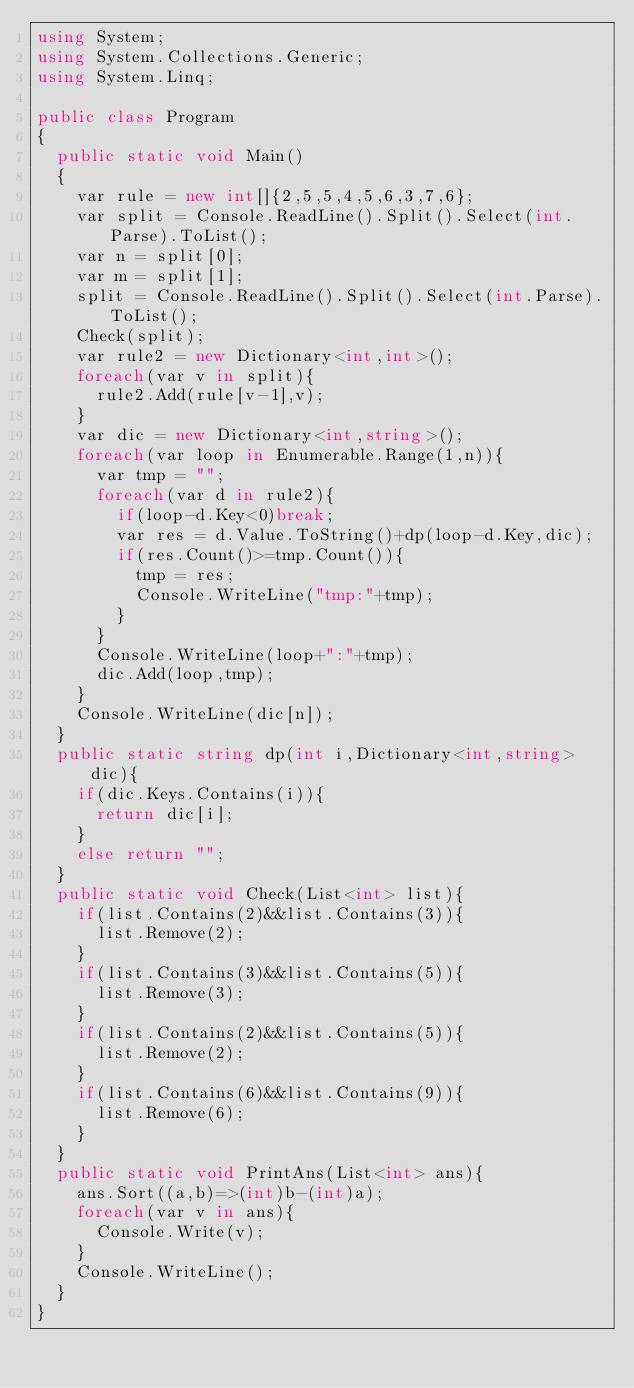<code> <loc_0><loc_0><loc_500><loc_500><_C#_>using System;
using System.Collections.Generic;
using System.Linq;
 
public class Program
{
	public static void Main()
	{
		var rule = new int[]{2,5,5,4,5,6,3,7,6};
		var split = Console.ReadLine().Split().Select(int.Parse).ToList();
		var n = split[0];
		var m = split[1];
		split = Console.ReadLine().Split().Select(int.Parse).ToList();
		Check(split);
		var rule2 = new Dictionary<int,int>();
		foreach(var v in split){
			rule2.Add(rule[v-1],v);
		}
		var dic = new Dictionary<int,string>();
		foreach(var loop in Enumerable.Range(1,n)){
			var tmp = "";
			foreach(var d in rule2){
				if(loop-d.Key<0)break;
				var res = d.Value.ToString()+dp(loop-d.Key,dic);
				if(res.Count()>=tmp.Count()){
					tmp = res;
					Console.WriteLine("tmp:"+tmp);
				}
			}
			Console.WriteLine(loop+":"+tmp);
			dic.Add(loop,tmp);
		}
		Console.WriteLine(dic[n]);
	}
	public static string dp(int i,Dictionary<int,string> dic){
		if(dic.Keys.Contains(i)){
			return dic[i];
		}
		else return "";
	}
	public static void Check(List<int> list){
		if(list.Contains(2)&&list.Contains(3)){
			list.Remove(2);
		}
		if(list.Contains(3)&&list.Contains(5)){
			list.Remove(3);
		}
		if(list.Contains(2)&&list.Contains(5)){
			list.Remove(2);
		}
		if(list.Contains(6)&&list.Contains(9)){
			list.Remove(6);
		}
	}
	public static void PrintAns(List<int> ans){
		ans.Sort((a,b)=>(int)b-(int)a);
		foreach(var v in ans){
			Console.Write(v);
		}
		Console.WriteLine();
	}
}
</code> 